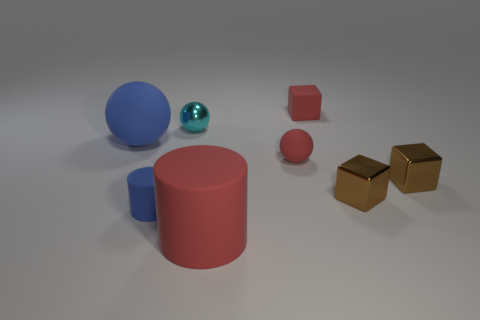Add 2 large blue rubber spheres. How many objects exist? 10 Subtract all cylinders. How many objects are left? 6 Add 3 big spheres. How many big spheres exist? 4 Subtract 0 gray balls. How many objects are left? 8 Subtract all small red things. Subtract all red matte objects. How many objects are left? 3 Add 1 red matte spheres. How many red matte spheres are left? 2 